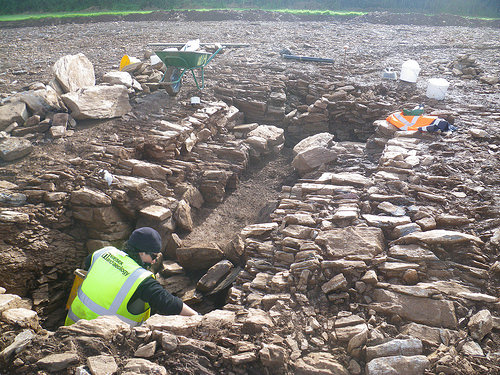<image>
Is the wheelbarrow next to the man? No. The wheelbarrow is not positioned next to the man. They are located in different areas of the scene. 